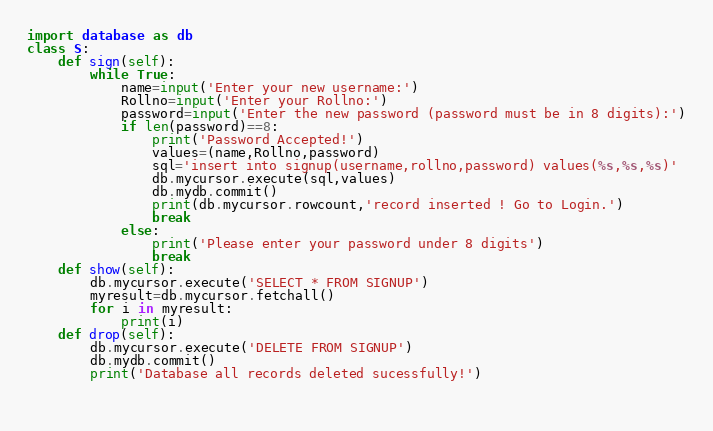<code> <loc_0><loc_0><loc_500><loc_500><_Python_>import database as db
class S:
    def sign(self):
        while True:
            name=input('Enter your new username:')
            Rollno=input('Enter your Rollno:')
            password=input('Enter the new password (password must be in 8 digits):')
            if len(password)==8:
                print('Password Accepted!')
                values=(name,Rollno,password)
                sql='insert into signup(username,rollno,password) values(%s,%s,%s)'
                db.mycursor.execute(sql,values)
                db.mydb.commit()
                print(db.mycursor.rowcount,'record inserted ! Go to Login.')
                break
            else:
                print('Please enter your password under 8 digits')
                break
    def show(self):
        db.mycursor.execute('SELECT * FROM SIGNUP')
        myresult=db.mycursor.fetchall()
        for i in myresult:
            print(i)
    def drop(self):
        db.mycursor.execute('DELETE FROM SIGNUP')
        db.mydb.commit()
        print('Database all records deleted sucessfully!') 
        
         
</code> 